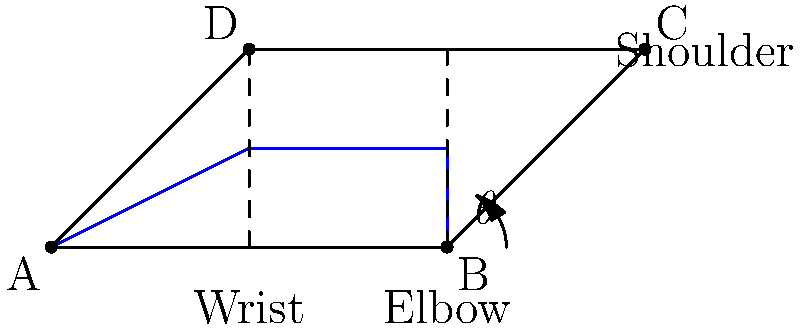When applying handcuffs, what is the optimal angle $\theta$ for the suspect's elbow to minimize the risk of injury and maximize control? To determine the optimal elbow angle for handcuffing, we need to consider several biomechanical factors:

1. Joint stress: An angle too acute can cause undue stress on the elbow joint.
2. Muscle tension: Extreme angles can lead to increased muscle tension, making the suspect more likely to resist.
3. Control: The angle should allow for maximum control by the officer.
4. Pain compliance: A slight discomfort can aid in compliance without causing injury.

Research in law enforcement biomechanics suggests:

1. A fully extended arm (180°) allows for too much mobility.
2. A severely bent elbow (< 45°) can cause joint damage.
3. An angle between 70° and 90° provides a balance of control and safety.

The optimal angle is generally considered to be around 80°. This angle:

1. Reduces the suspect's leverage.
2. Maintains joint integrity.
3. Allows for pain compliance if needed.
4. Provides the officer with maximum control.

Therefore, the optimal elbow angle $\theta$ for handcuffing is approximately 80°.
Answer: Approximately 80° 